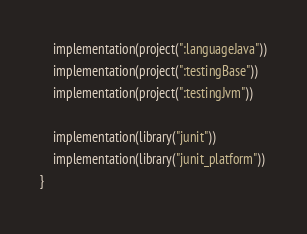Convert code to text. <code><loc_0><loc_0><loc_500><loc_500><_Kotlin_>    implementation(project(":languageJava"))
    implementation(project(":testingBase"))
    implementation(project(":testingJvm"))

    implementation(library("junit"))
    implementation(library("junit_platform"))
}
</code> 